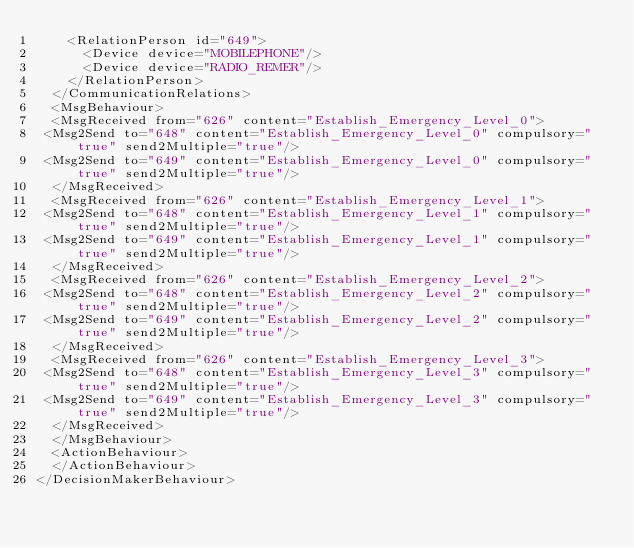Convert code to text. <code><loc_0><loc_0><loc_500><loc_500><_XML_>    <RelationPerson id="649">
      <Device device="MOBILEPHONE"/>
      <Device device="RADIO_REMER"/>
    </RelationPerson>
  </CommunicationRelations>
  <MsgBehaviour>
  <MsgReceived from="626" content="Establish_Emergency_Level_0">
 <Msg2Send to="648" content="Establish_Emergency_Level_0" compulsory="true" send2Multiple="true"/>
 <Msg2Send to="649" content="Establish_Emergency_Level_0" compulsory="true" send2Multiple="true"/>
  </MsgReceived>
  <MsgReceived from="626" content="Establish_Emergency_Level_1">
 <Msg2Send to="648" content="Establish_Emergency_Level_1" compulsory="true" send2Multiple="true"/>
 <Msg2Send to="649" content="Establish_Emergency_Level_1" compulsory="true" send2Multiple="true"/>
  </MsgReceived>
  <MsgReceived from="626" content="Establish_Emergency_Level_2">
 <Msg2Send to="648" content="Establish_Emergency_Level_2" compulsory="true" send2Multiple="true"/>
 <Msg2Send to="649" content="Establish_Emergency_Level_2" compulsory="true" send2Multiple="true"/>
  </MsgReceived>
  <MsgReceived from="626" content="Establish_Emergency_Level_3">
 <Msg2Send to="648" content="Establish_Emergency_Level_3" compulsory="true" send2Multiple="true"/>
 <Msg2Send to="649" content="Establish_Emergency_Level_3" compulsory="true" send2Multiple="true"/>
  </MsgReceived>
  </MsgBehaviour>
  <ActionBehaviour>
  </ActionBehaviour>
</DecisionMakerBehaviour>
</code> 